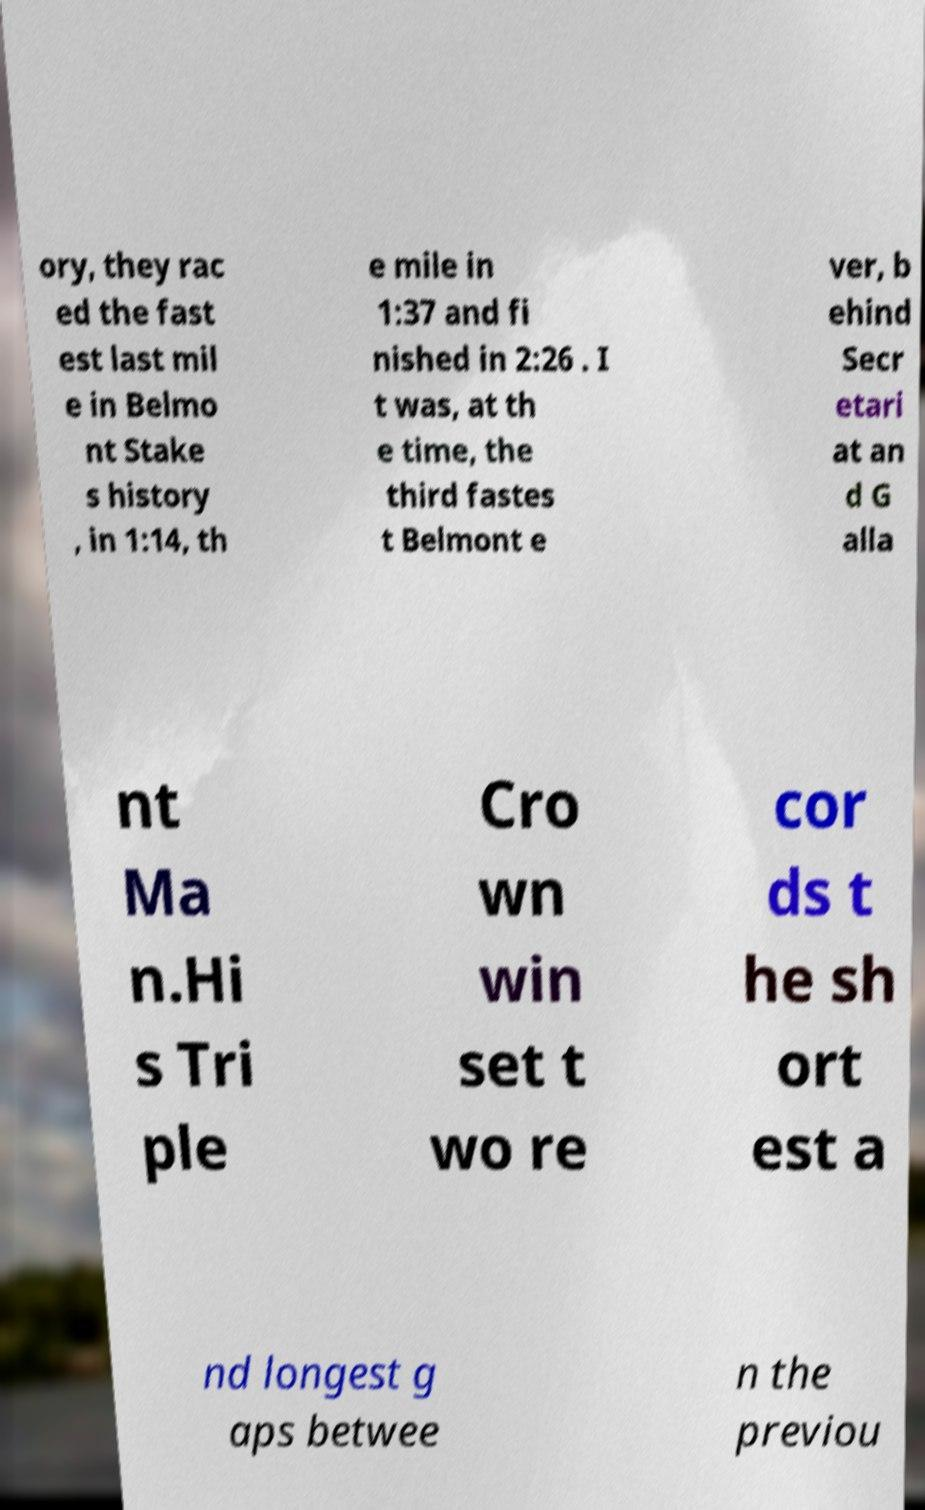Please read and relay the text visible in this image. What does it say? ory, they rac ed the fast est last mil e in Belmo nt Stake s history , in 1:14, th e mile in 1:37 and fi nished in 2:26 . I t was, at th e time, the third fastes t Belmont e ver, b ehind Secr etari at an d G alla nt Ma n.Hi s Tri ple Cro wn win set t wo re cor ds t he sh ort est a nd longest g aps betwee n the previou 